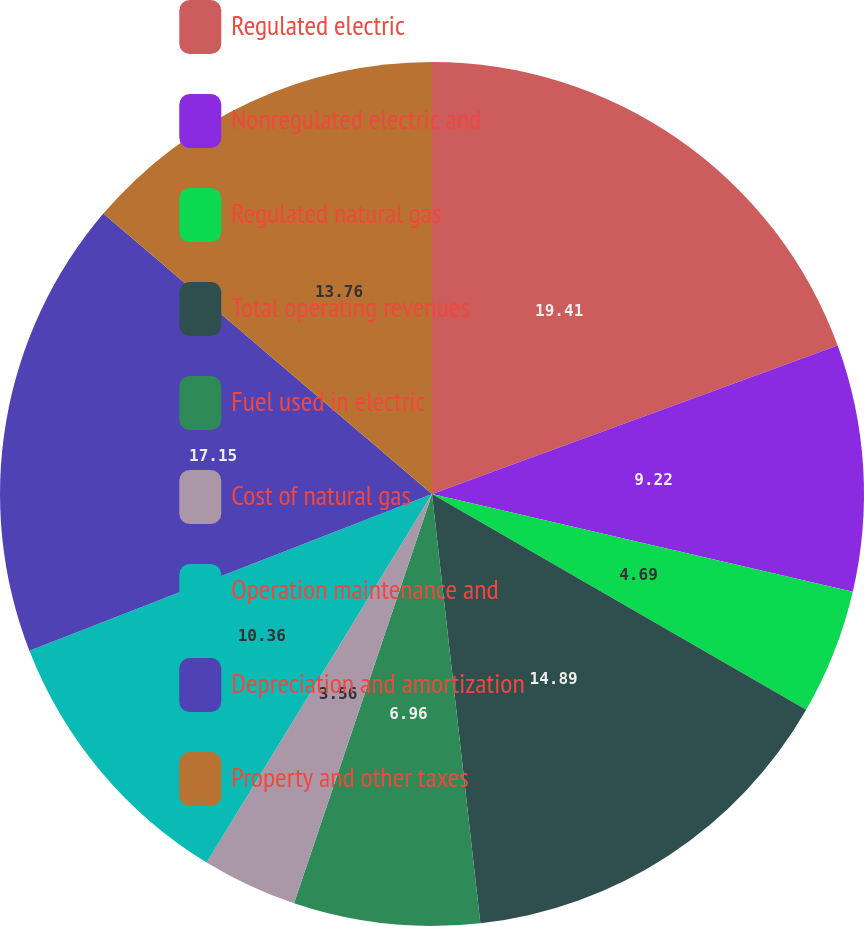Convert chart to OTSL. <chart><loc_0><loc_0><loc_500><loc_500><pie_chart><fcel>Regulated electric<fcel>Nonregulated electric and<fcel>Regulated natural gas<fcel>Total operating revenues<fcel>Fuel used in electric<fcel>Cost of natural gas<fcel>Operation maintenance and<fcel>Depreciation and amortization<fcel>Property and other taxes<nl><fcel>19.42%<fcel>9.22%<fcel>4.69%<fcel>14.89%<fcel>6.96%<fcel>3.56%<fcel>10.36%<fcel>17.15%<fcel>13.76%<nl></chart> 